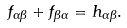<formula> <loc_0><loc_0><loc_500><loc_500>f _ { \alpha \beta } + f _ { \beta \alpha } = h _ { \alpha \beta } .</formula> 